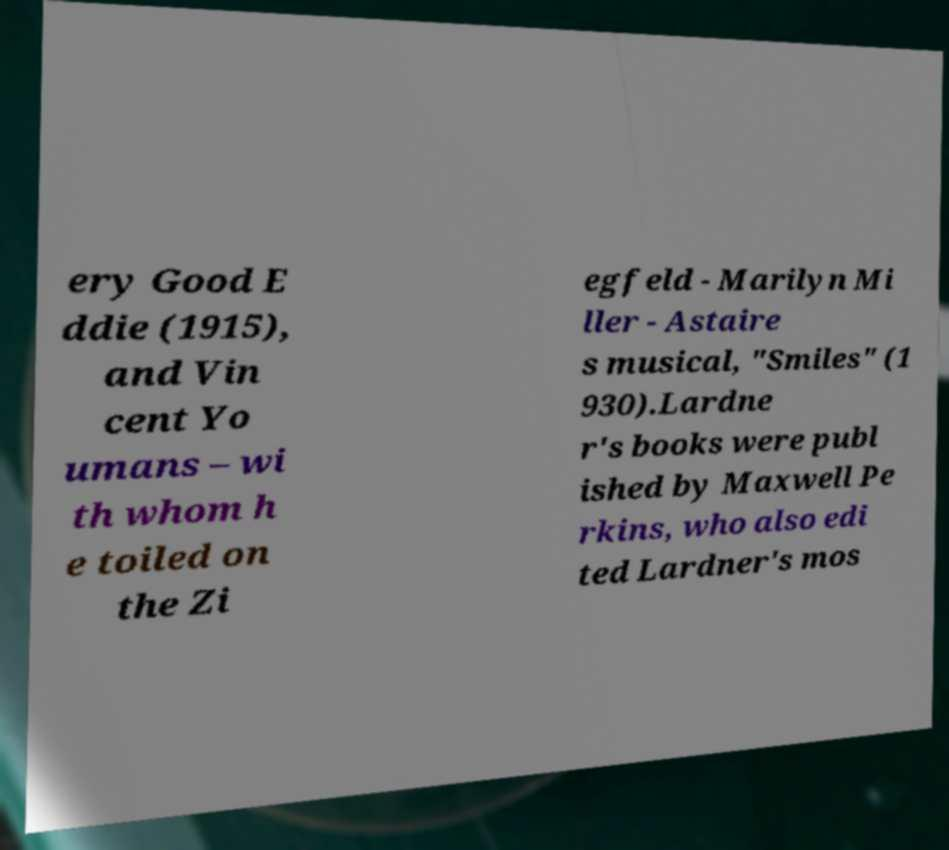For documentation purposes, I need the text within this image transcribed. Could you provide that? ery Good E ddie (1915), and Vin cent Yo umans – wi th whom h e toiled on the Zi egfeld - Marilyn Mi ller - Astaire s musical, "Smiles" (1 930).Lardne r's books were publ ished by Maxwell Pe rkins, who also edi ted Lardner's mos 